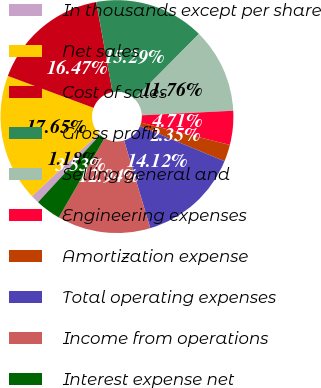Convert chart to OTSL. <chart><loc_0><loc_0><loc_500><loc_500><pie_chart><fcel>In thousands except per share<fcel>Net sales<fcel>Cost of sales<fcel>Gross profit<fcel>Selling general and<fcel>Engineering expenses<fcel>Amortization expense<fcel>Total operating expenses<fcel>Income from operations<fcel>Interest expense net<nl><fcel>1.18%<fcel>17.65%<fcel>16.47%<fcel>15.29%<fcel>11.76%<fcel>4.71%<fcel>2.35%<fcel>14.12%<fcel>12.94%<fcel>3.53%<nl></chart> 